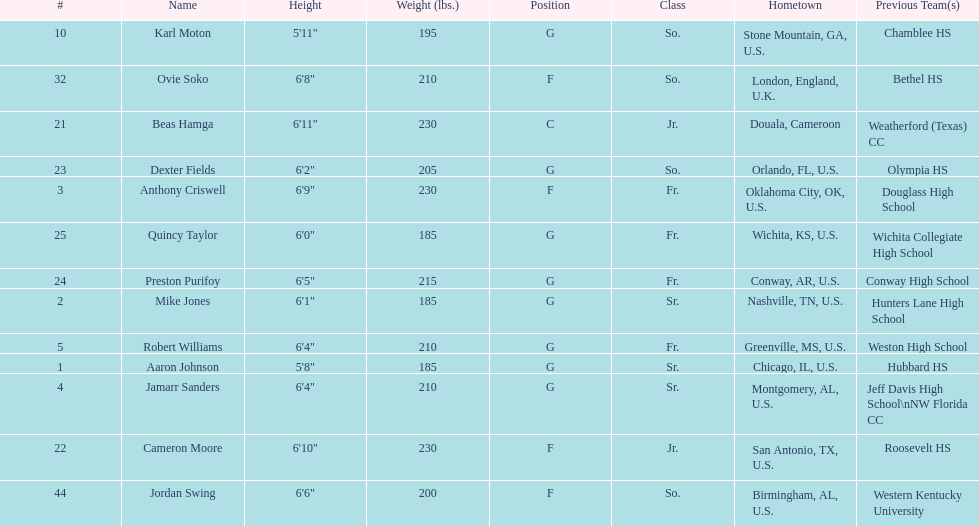How many players come from alabama? 2. 